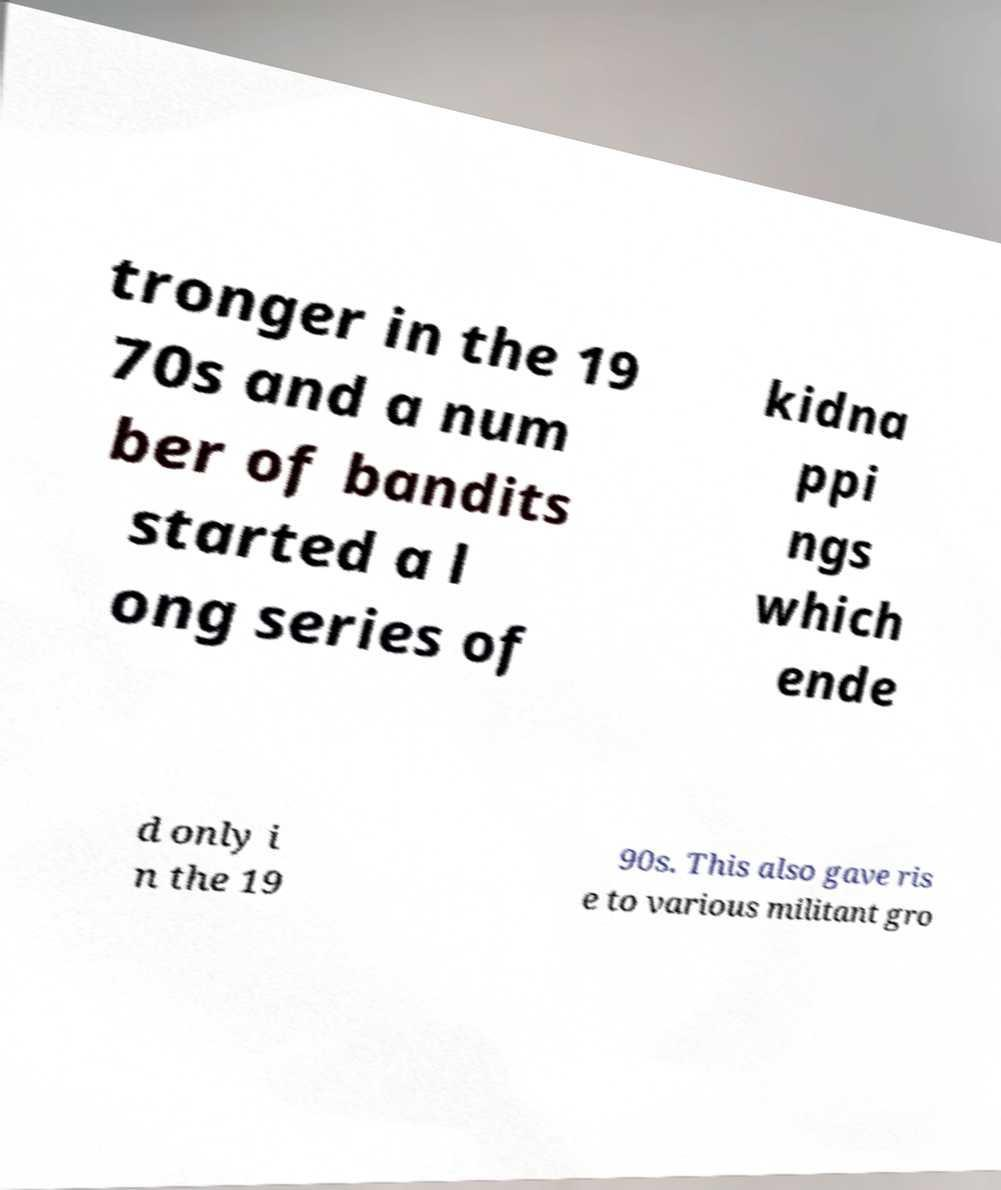For documentation purposes, I need the text within this image transcribed. Could you provide that? tronger in the 19 70s and a num ber of bandits started a l ong series of kidna ppi ngs which ende d only i n the 19 90s. This also gave ris e to various militant gro 